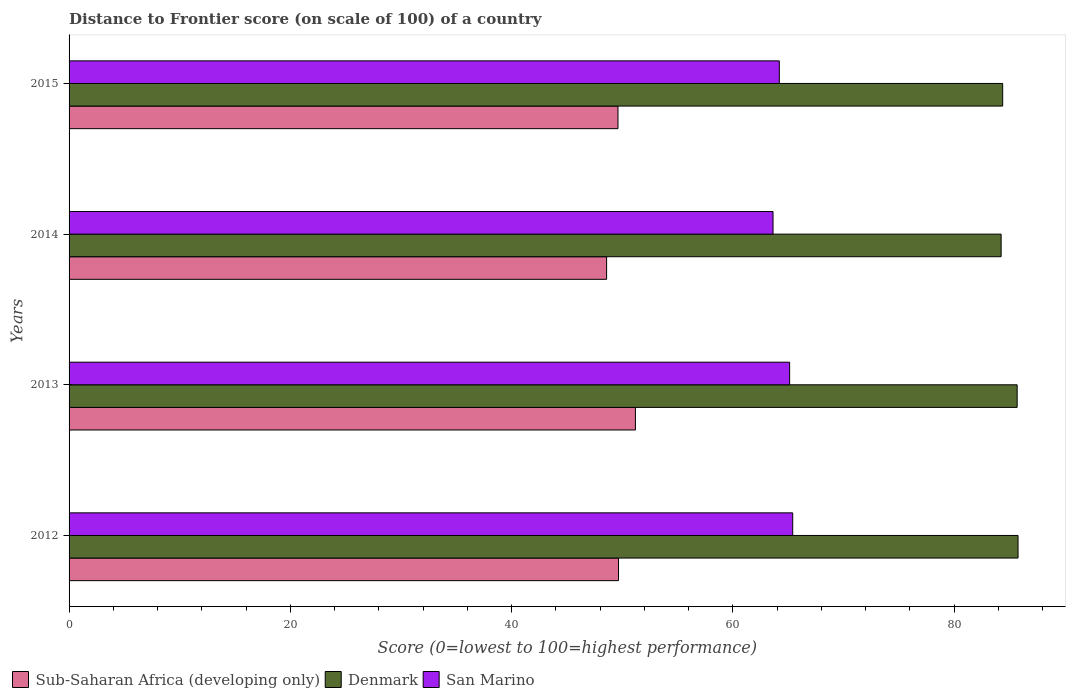Are the number of bars per tick equal to the number of legend labels?
Keep it short and to the point. Yes. How many bars are there on the 3rd tick from the bottom?
Provide a short and direct response. 3. What is the label of the 2nd group of bars from the top?
Give a very brief answer. 2014. In how many cases, is the number of bars for a given year not equal to the number of legend labels?
Keep it short and to the point. 0. What is the distance to frontier score of in San Marino in 2014?
Your response must be concise. 63.64. Across all years, what is the maximum distance to frontier score of in Sub-Saharan Africa (developing only)?
Offer a terse response. 51.2. Across all years, what is the minimum distance to frontier score of in San Marino?
Your answer should be very brief. 63.64. In which year was the distance to frontier score of in Sub-Saharan Africa (developing only) maximum?
Make the answer very short. 2013. What is the total distance to frontier score of in Sub-Saharan Africa (developing only) in the graph?
Make the answer very short. 199.09. What is the difference between the distance to frontier score of in Sub-Saharan Africa (developing only) in 2013 and that in 2015?
Ensure brevity in your answer.  1.58. What is the difference between the distance to frontier score of in Denmark in 2014 and the distance to frontier score of in Sub-Saharan Africa (developing only) in 2015?
Your answer should be very brief. 34.64. What is the average distance to frontier score of in Sub-Saharan Africa (developing only) per year?
Offer a very short reply. 49.77. In the year 2014, what is the difference between the distance to frontier score of in Sub-Saharan Africa (developing only) and distance to frontier score of in Denmark?
Your answer should be very brief. -35.66. In how many years, is the distance to frontier score of in San Marino greater than 76 ?
Your response must be concise. 0. What is the ratio of the distance to frontier score of in Denmark in 2012 to that in 2015?
Offer a very short reply. 1.02. Is the distance to frontier score of in Sub-Saharan Africa (developing only) in 2012 less than that in 2015?
Make the answer very short. No. Is the difference between the distance to frontier score of in Sub-Saharan Africa (developing only) in 2013 and 2014 greater than the difference between the distance to frontier score of in Denmark in 2013 and 2014?
Your answer should be very brief. Yes. What is the difference between the highest and the second highest distance to frontier score of in Denmark?
Ensure brevity in your answer.  0.08. What is the difference between the highest and the lowest distance to frontier score of in Sub-Saharan Africa (developing only)?
Provide a short and direct response. 2.6. In how many years, is the distance to frontier score of in San Marino greater than the average distance to frontier score of in San Marino taken over all years?
Make the answer very short. 2. What does the 3rd bar from the top in 2015 represents?
Keep it short and to the point. Sub-Saharan Africa (developing only). What does the 3rd bar from the bottom in 2014 represents?
Offer a very short reply. San Marino. Is it the case that in every year, the sum of the distance to frontier score of in Denmark and distance to frontier score of in San Marino is greater than the distance to frontier score of in Sub-Saharan Africa (developing only)?
Make the answer very short. Yes. How many bars are there?
Provide a short and direct response. 12. Are all the bars in the graph horizontal?
Give a very brief answer. Yes. How many years are there in the graph?
Provide a succinct answer. 4. What is the difference between two consecutive major ticks on the X-axis?
Make the answer very short. 20. Are the values on the major ticks of X-axis written in scientific E-notation?
Ensure brevity in your answer.  No. Does the graph contain any zero values?
Your answer should be very brief. No. Does the graph contain grids?
Your answer should be very brief. No. Where does the legend appear in the graph?
Your answer should be very brief. Bottom left. What is the title of the graph?
Provide a succinct answer. Distance to Frontier score (on scale of 100) of a country. What is the label or title of the X-axis?
Your answer should be very brief. Score (0=lowest to 100=highest performance). What is the label or title of the Y-axis?
Keep it short and to the point. Years. What is the Score (0=lowest to 100=highest performance) in Sub-Saharan Africa (developing only) in 2012?
Keep it short and to the point. 49.67. What is the Score (0=lowest to 100=highest performance) of Denmark in 2012?
Give a very brief answer. 85.79. What is the Score (0=lowest to 100=highest performance) in San Marino in 2012?
Your response must be concise. 65.42. What is the Score (0=lowest to 100=highest performance) of Sub-Saharan Africa (developing only) in 2013?
Keep it short and to the point. 51.2. What is the Score (0=lowest to 100=highest performance) in Denmark in 2013?
Offer a very short reply. 85.71. What is the Score (0=lowest to 100=highest performance) in San Marino in 2013?
Your response must be concise. 65.14. What is the Score (0=lowest to 100=highest performance) of Sub-Saharan Africa (developing only) in 2014?
Your answer should be very brief. 48.6. What is the Score (0=lowest to 100=highest performance) in Denmark in 2014?
Your response must be concise. 84.26. What is the Score (0=lowest to 100=highest performance) of San Marino in 2014?
Your answer should be very brief. 63.64. What is the Score (0=lowest to 100=highest performance) in Sub-Saharan Africa (developing only) in 2015?
Make the answer very short. 49.62. What is the Score (0=lowest to 100=highest performance) in Denmark in 2015?
Your answer should be very brief. 84.4. What is the Score (0=lowest to 100=highest performance) in San Marino in 2015?
Offer a very short reply. 64.21. Across all years, what is the maximum Score (0=lowest to 100=highest performance) of Sub-Saharan Africa (developing only)?
Your answer should be very brief. 51.2. Across all years, what is the maximum Score (0=lowest to 100=highest performance) in Denmark?
Provide a short and direct response. 85.79. Across all years, what is the maximum Score (0=lowest to 100=highest performance) of San Marino?
Your answer should be compact. 65.42. Across all years, what is the minimum Score (0=lowest to 100=highest performance) of Sub-Saharan Africa (developing only)?
Offer a very short reply. 48.6. Across all years, what is the minimum Score (0=lowest to 100=highest performance) in Denmark?
Your response must be concise. 84.26. Across all years, what is the minimum Score (0=lowest to 100=highest performance) in San Marino?
Your response must be concise. 63.64. What is the total Score (0=lowest to 100=highest performance) of Sub-Saharan Africa (developing only) in the graph?
Give a very brief answer. 199.09. What is the total Score (0=lowest to 100=highest performance) of Denmark in the graph?
Your response must be concise. 340.16. What is the total Score (0=lowest to 100=highest performance) of San Marino in the graph?
Keep it short and to the point. 258.41. What is the difference between the Score (0=lowest to 100=highest performance) of Sub-Saharan Africa (developing only) in 2012 and that in 2013?
Your answer should be compact. -1.53. What is the difference between the Score (0=lowest to 100=highest performance) of Denmark in 2012 and that in 2013?
Provide a short and direct response. 0.08. What is the difference between the Score (0=lowest to 100=highest performance) in San Marino in 2012 and that in 2013?
Your answer should be very brief. 0.28. What is the difference between the Score (0=lowest to 100=highest performance) in Sub-Saharan Africa (developing only) in 2012 and that in 2014?
Offer a very short reply. 1.08. What is the difference between the Score (0=lowest to 100=highest performance) in Denmark in 2012 and that in 2014?
Keep it short and to the point. 1.53. What is the difference between the Score (0=lowest to 100=highest performance) in San Marino in 2012 and that in 2014?
Your answer should be very brief. 1.78. What is the difference between the Score (0=lowest to 100=highest performance) of Sub-Saharan Africa (developing only) in 2012 and that in 2015?
Provide a succinct answer. 0.05. What is the difference between the Score (0=lowest to 100=highest performance) of Denmark in 2012 and that in 2015?
Give a very brief answer. 1.39. What is the difference between the Score (0=lowest to 100=highest performance) in San Marino in 2012 and that in 2015?
Give a very brief answer. 1.21. What is the difference between the Score (0=lowest to 100=highest performance) in Sub-Saharan Africa (developing only) in 2013 and that in 2014?
Make the answer very short. 2.6. What is the difference between the Score (0=lowest to 100=highest performance) of Denmark in 2013 and that in 2014?
Offer a very short reply. 1.45. What is the difference between the Score (0=lowest to 100=highest performance) of Sub-Saharan Africa (developing only) in 2013 and that in 2015?
Offer a terse response. 1.58. What is the difference between the Score (0=lowest to 100=highest performance) in Denmark in 2013 and that in 2015?
Offer a very short reply. 1.31. What is the difference between the Score (0=lowest to 100=highest performance) of Sub-Saharan Africa (developing only) in 2014 and that in 2015?
Your answer should be compact. -1.03. What is the difference between the Score (0=lowest to 100=highest performance) of Denmark in 2014 and that in 2015?
Ensure brevity in your answer.  -0.14. What is the difference between the Score (0=lowest to 100=highest performance) of San Marino in 2014 and that in 2015?
Provide a short and direct response. -0.57. What is the difference between the Score (0=lowest to 100=highest performance) in Sub-Saharan Africa (developing only) in 2012 and the Score (0=lowest to 100=highest performance) in Denmark in 2013?
Give a very brief answer. -36.04. What is the difference between the Score (0=lowest to 100=highest performance) of Sub-Saharan Africa (developing only) in 2012 and the Score (0=lowest to 100=highest performance) of San Marino in 2013?
Give a very brief answer. -15.47. What is the difference between the Score (0=lowest to 100=highest performance) of Denmark in 2012 and the Score (0=lowest to 100=highest performance) of San Marino in 2013?
Give a very brief answer. 20.65. What is the difference between the Score (0=lowest to 100=highest performance) of Sub-Saharan Africa (developing only) in 2012 and the Score (0=lowest to 100=highest performance) of Denmark in 2014?
Ensure brevity in your answer.  -34.59. What is the difference between the Score (0=lowest to 100=highest performance) in Sub-Saharan Africa (developing only) in 2012 and the Score (0=lowest to 100=highest performance) in San Marino in 2014?
Provide a succinct answer. -13.97. What is the difference between the Score (0=lowest to 100=highest performance) in Denmark in 2012 and the Score (0=lowest to 100=highest performance) in San Marino in 2014?
Keep it short and to the point. 22.15. What is the difference between the Score (0=lowest to 100=highest performance) in Sub-Saharan Africa (developing only) in 2012 and the Score (0=lowest to 100=highest performance) in Denmark in 2015?
Your answer should be compact. -34.73. What is the difference between the Score (0=lowest to 100=highest performance) of Sub-Saharan Africa (developing only) in 2012 and the Score (0=lowest to 100=highest performance) of San Marino in 2015?
Your response must be concise. -14.54. What is the difference between the Score (0=lowest to 100=highest performance) in Denmark in 2012 and the Score (0=lowest to 100=highest performance) in San Marino in 2015?
Your answer should be very brief. 21.58. What is the difference between the Score (0=lowest to 100=highest performance) of Sub-Saharan Africa (developing only) in 2013 and the Score (0=lowest to 100=highest performance) of Denmark in 2014?
Keep it short and to the point. -33.06. What is the difference between the Score (0=lowest to 100=highest performance) in Sub-Saharan Africa (developing only) in 2013 and the Score (0=lowest to 100=highest performance) in San Marino in 2014?
Provide a succinct answer. -12.44. What is the difference between the Score (0=lowest to 100=highest performance) in Denmark in 2013 and the Score (0=lowest to 100=highest performance) in San Marino in 2014?
Your response must be concise. 22.07. What is the difference between the Score (0=lowest to 100=highest performance) of Sub-Saharan Africa (developing only) in 2013 and the Score (0=lowest to 100=highest performance) of Denmark in 2015?
Make the answer very short. -33.2. What is the difference between the Score (0=lowest to 100=highest performance) of Sub-Saharan Africa (developing only) in 2013 and the Score (0=lowest to 100=highest performance) of San Marino in 2015?
Give a very brief answer. -13.01. What is the difference between the Score (0=lowest to 100=highest performance) of Denmark in 2013 and the Score (0=lowest to 100=highest performance) of San Marino in 2015?
Your response must be concise. 21.5. What is the difference between the Score (0=lowest to 100=highest performance) in Sub-Saharan Africa (developing only) in 2014 and the Score (0=lowest to 100=highest performance) in Denmark in 2015?
Your answer should be compact. -35.8. What is the difference between the Score (0=lowest to 100=highest performance) of Sub-Saharan Africa (developing only) in 2014 and the Score (0=lowest to 100=highest performance) of San Marino in 2015?
Provide a succinct answer. -15.61. What is the difference between the Score (0=lowest to 100=highest performance) of Denmark in 2014 and the Score (0=lowest to 100=highest performance) of San Marino in 2015?
Make the answer very short. 20.05. What is the average Score (0=lowest to 100=highest performance) of Sub-Saharan Africa (developing only) per year?
Provide a succinct answer. 49.77. What is the average Score (0=lowest to 100=highest performance) of Denmark per year?
Provide a succinct answer. 85.04. What is the average Score (0=lowest to 100=highest performance) in San Marino per year?
Ensure brevity in your answer.  64.6. In the year 2012, what is the difference between the Score (0=lowest to 100=highest performance) in Sub-Saharan Africa (developing only) and Score (0=lowest to 100=highest performance) in Denmark?
Provide a succinct answer. -36.12. In the year 2012, what is the difference between the Score (0=lowest to 100=highest performance) of Sub-Saharan Africa (developing only) and Score (0=lowest to 100=highest performance) of San Marino?
Provide a succinct answer. -15.75. In the year 2012, what is the difference between the Score (0=lowest to 100=highest performance) of Denmark and Score (0=lowest to 100=highest performance) of San Marino?
Provide a short and direct response. 20.37. In the year 2013, what is the difference between the Score (0=lowest to 100=highest performance) in Sub-Saharan Africa (developing only) and Score (0=lowest to 100=highest performance) in Denmark?
Ensure brevity in your answer.  -34.51. In the year 2013, what is the difference between the Score (0=lowest to 100=highest performance) in Sub-Saharan Africa (developing only) and Score (0=lowest to 100=highest performance) in San Marino?
Keep it short and to the point. -13.94. In the year 2013, what is the difference between the Score (0=lowest to 100=highest performance) in Denmark and Score (0=lowest to 100=highest performance) in San Marino?
Make the answer very short. 20.57. In the year 2014, what is the difference between the Score (0=lowest to 100=highest performance) of Sub-Saharan Africa (developing only) and Score (0=lowest to 100=highest performance) of Denmark?
Offer a very short reply. -35.66. In the year 2014, what is the difference between the Score (0=lowest to 100=highest performance) of Sub-Saharan Africa (developing only) and Score (0=lowest to 100=highest performance) of San Marino?
Your answer should be very brief. -15.04. In the year 2014, what is the difference between the Score (0=lowest to 100=highest performance) of Denmark and Score (0=lowest to 100=highest performance) of San Marino?
Give a very brief answer. 20.62. In the year 2015, what is the difference between the Score (0=lowest to 100=highest performance) in Sub-Saharan Africa (developing only) and Score (0=lowest to 100=highest performance) in Denmark?
Your answer should be compact. -34.78. In the year 2015, what is the difference between the Score (0=lowest to 100=highest performance) of Sub-Saharan Africa (developing only) and Score (0=lowest to 100=highest performance) of San Marino?
Your answer should be compact. -14.59. In the year 2015, what is the difference between the Score (0=lowest to 100=highest performance) in Denmark and Score (0=lowest to 100=highest performance) in San Marino?
Give a very brief answer. 20.19. What is the ratio of the Score (0=lowest to 100=highest performance) in Sub-Saharan Africa (developing only) in 2012 to that in 2013?
Your answer should be compact. 0.97. What is the ratio of the Score (0=lowest to 100=highest performance) of Denmark in 2012 to that in 2013?
Your answer should be compact. 1. What is the ratio of the Score (0=lowest to 100=highest performance) of San Marino in 2012 to that in 2013?
Give a very brief answer. 1. What is the ratio of the Score (0=lowest to 100=highest performance) in Sub-Saharan Africa (developing only) in 2012 to that in 2014?
Offer a very short reply. 1.02. What is the ratio of the Score (0=lowest to 100=highest performance) in Denmark in 2012 to that in 2014?
Provide a succinct answer. 1.02. What is the ratio of the Score (0=lowest to 100=highest performance) of San Marino in 2012 to that in 2014?
Keep it short and to the point. 1.03. What is the ratio of the Score (0=lowest to 100=highest performance) in Sub-Saharan Africa (developing only) in 2012 to that in 2015?
Make the answer very short. 1. What is the ratio of the Score (0=lowest to 100=highest performance) of Denmark in 2012 to that in 2015?
Keep it short and to the point. 1.02. What is the ratio of the Score (0=lowest to 100=highest performance) of San Marino in 2012 to that in 2015?
Provide a short and direct response. 1.02. What is the ratio of the Score (0=lowest to 100=highest performance) in Sub-Saharan Africa (developing only) in 2013 to that in 2014?
Offer a terse response. 1.05. What is the ratio of the Score (0=lowest to 100=highest performance) in Denmark in 2013 to that in 2014?
Offer a terse response. 1.02. What is the ratio of the Score (0=lowest to 100=highest performance) of San Marino in 2013 to that in 2014?
Your response must be concise. 1.02. What is the ratio of the Score (0=lowest to 100=highest performance) of Sub-Saharan Africa (developing only) in 2013 to that in 2015?
Give a very brief answer. 1.03. What is the ratio of the Score (0=lowest to 100=highest performance) in Denmark in 2013 to that in 2015?
Your answer should be very brief. 1.02. What is the ratio of the Score (0=lowest to 100=highest performance) in San Marino in 2013 to that in 2015?
Your answer should be compact. 1.01. What is the ratio of the Score (0=lowest to 100=highest performance) of Sub-Saharan Africa (developing only) in 2014 to that in 2015?
Your response must be concise. 0.98. What is the ratio of the Score (0=lowest to 100=highest performance) of Denmark in 2014 to that in 2015?
Your response must be concise. 1. What is the difference between the highest and the second highest Score (0=lowest to 100=highest performance) in Sub-Saharan Africa (developing only)?
Give a very brief answer. 1.53. What is the difference between the highest and the second highest Score (0=lowest to 100=highest performance) of San Marino?
Offer a terse response. 0.28. What is the difference between the highest and the lowest Score (0=lowest to 100=highest performance) of Sub-Saharan Africa (developing only)?
Offer a terse response. 2.6. What is the difference between the highest and the lowest Score (0=lowest to 100=highest performance) of Denmark?
Your response must be concise. 1.53. What is the difference between the highest and the lowest Score (0=lowest to 100=highest performance) in San Marino?
Your answer should be compact. 1.78. 